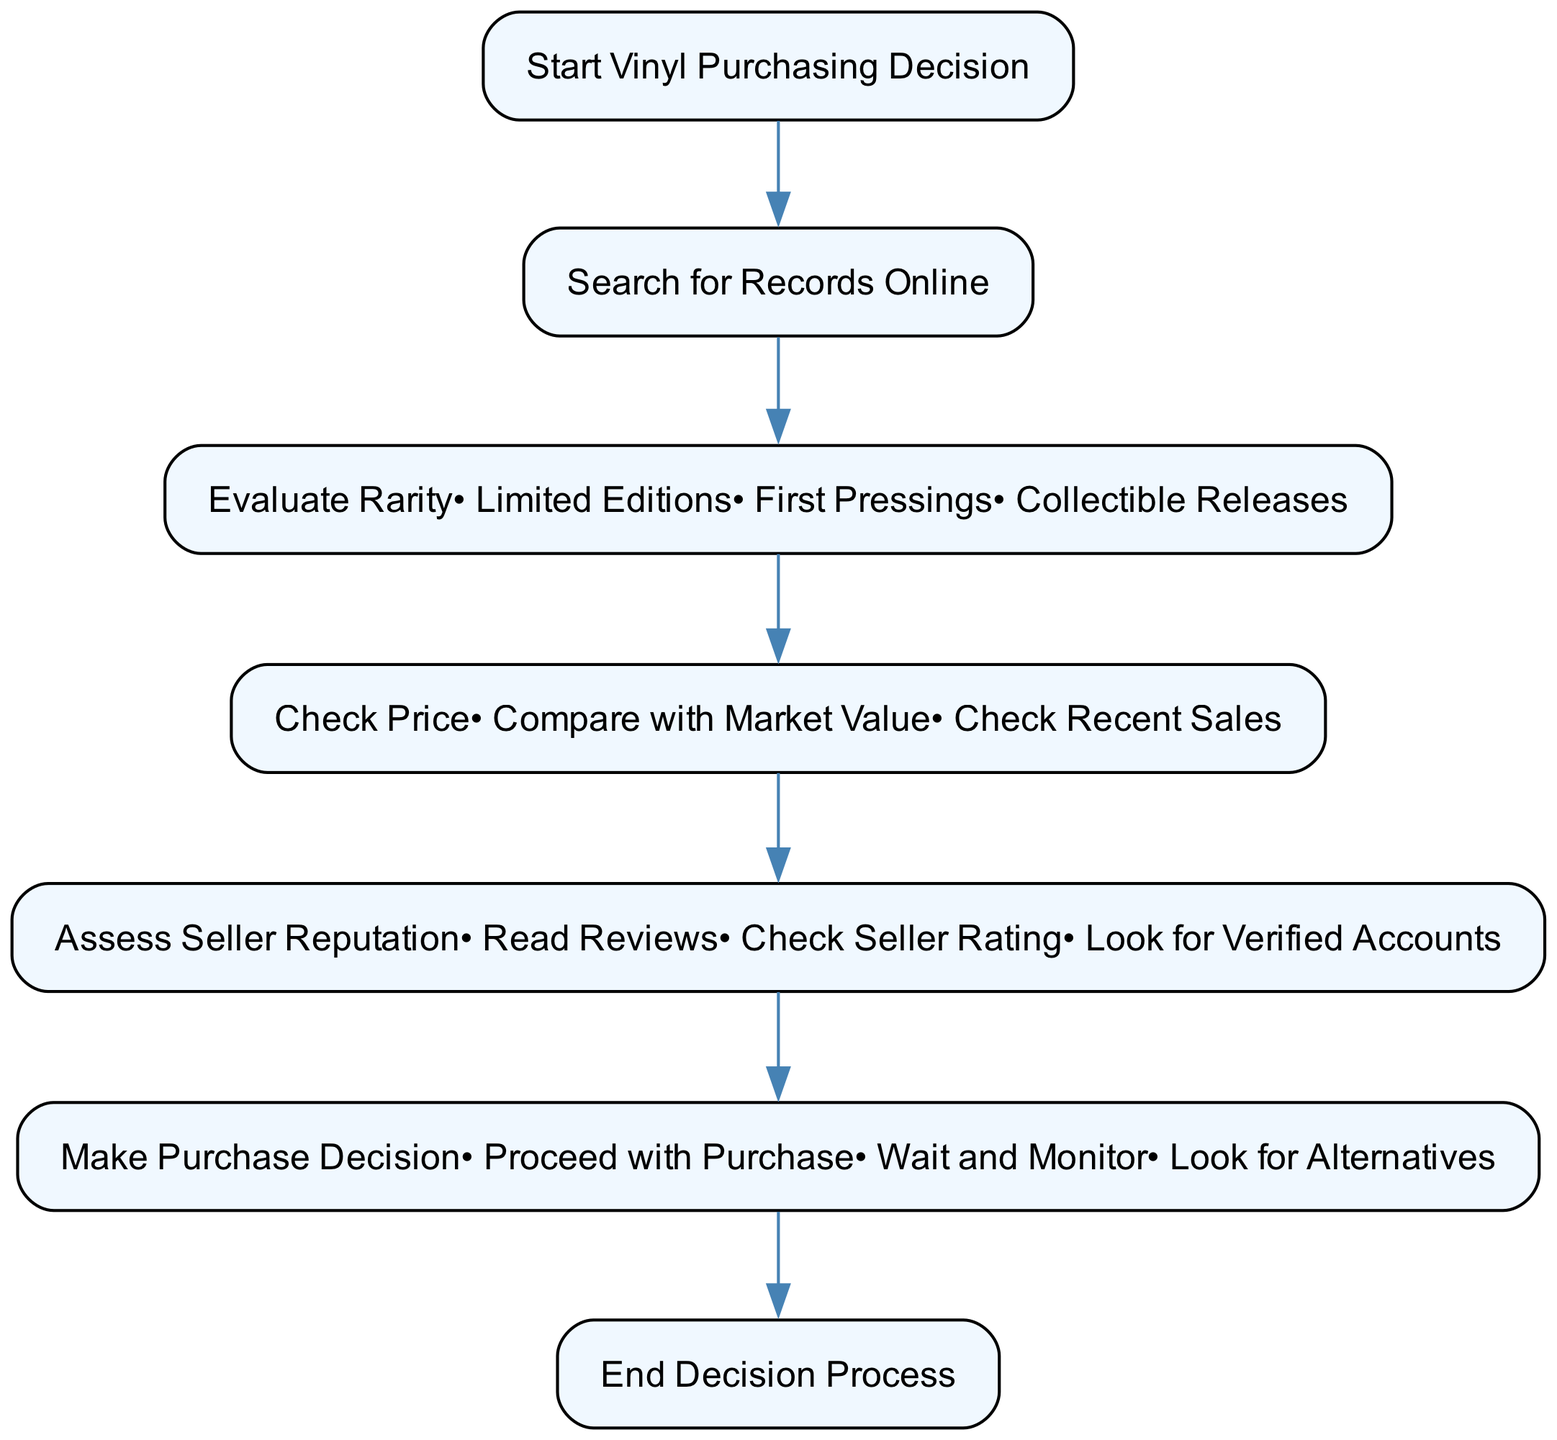What is the first step in the decision process? The first step is indicated by the starting node labeled "Start Vinyl Purchasing Decision". After that, the process flows into searching for records online.
Answer: Start Vinyl Purchasing Decision How many options are available for assessing seller reputation? In the "Assess Seller Reputation" node, there are three options: "Read Reviews", "Check Seller Rating", and "Look for Verified Accounts". Count these options to find the answer.
Answer: Three What is the final node in the flow chart? The final node in the flow chart represents the conclusion of the decision-making process, labeled "End Decision Process". This shows that the decision is completed.
Answer: End Decision Process Which node comes right after checking price? The flow chart connects the "Check Price" node to the next step, which is "Assess Seller Reputation". This indicates the sequence in the decision-making process.
Answer: Assess Seller Reputation What are the different ways to evaluate rarity? The "Evaluate Rarity" node includes options for evaluating rarity: "Limited Editions", "First Pressings", and "Collectible Releases". Listing these provides a clear answer.
Answer: Limited Editions, First Pressings, Collectible Releases How many connections are there in the entire flow chart? By counting the edges between the nodes defined in the connections section, there are a total of 5 connections that represent the flow from one step to the next.
Answer: Five What decision may be made after assessing the seller reputation? According to the "Make Purchase Decision" node, the choices include "Proceed with Purchase", "Wait and Monitor", or "Look for Alternatives". This indicates potential actions after the assessment.
Answer: Proceed with Purchase, Wait and Monitor, Look for Alternatives What department is focused on after the record search? After the "Search for Records Online" step, the focus shifts towards "Evaluate Rarity", which is the subsequent node in the decision process. This reflects the logical next step after searching.
Answer: Evaluate Rarity Which option is included in checking price? Within the "Check Price" node, the options provided are "Compare with Market Value" and "Check Recent Sales", indicating how buyers should approach price checking.
Answer: Compare with Market Value, Check Recent Sales 